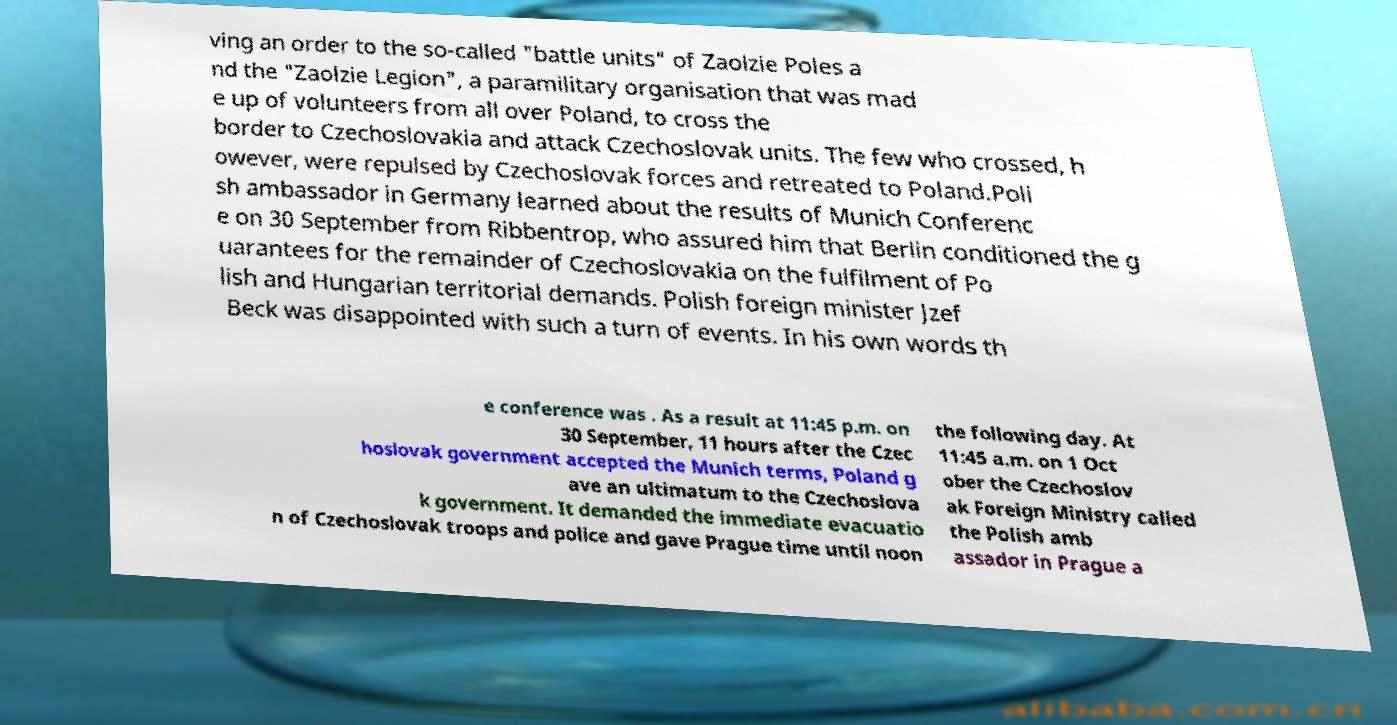Can you accurately transcribe the text from the provided image for me? ving an order to the so-called "battle units" of Zaolzie Poles a nd the "Zaolzie Legion", a paramilitary organisation that was mad e up of volunteers from all over Poland, to cross the border to Czechoslovakia and attack Czechoslovak units. The few who crossed, h owever, were repulsed by Czechoslovak forces and retreated to Poland.Poli sh ambassador in Germany learned about the results of Munich Conferenc e on 30 September from Ribbentrop, who assured him that Berlin conditioned the g uarantees for the remainder of Czechoslovakia on the fulfilment of Po lish and Hungarian territorial demands. Polish foreign minister Jzef Beck was disappointed with such a turn of events. In his own words th e conference was . As a result at 11:45 p.m. on 30 September, 11 hours after the Czec hoslovak government accepted the Munich terms, Poland g ave an ultimatum to the Czechoslova k government. It demanded the immediate evacuatio n of Czechoslovak troops and police and gave Prague time until noon the following day. At 11:45 a.m. on 1 Oct ober the Czechoslov ak Foreign Ministry called the Polish amb assador in Prague a 